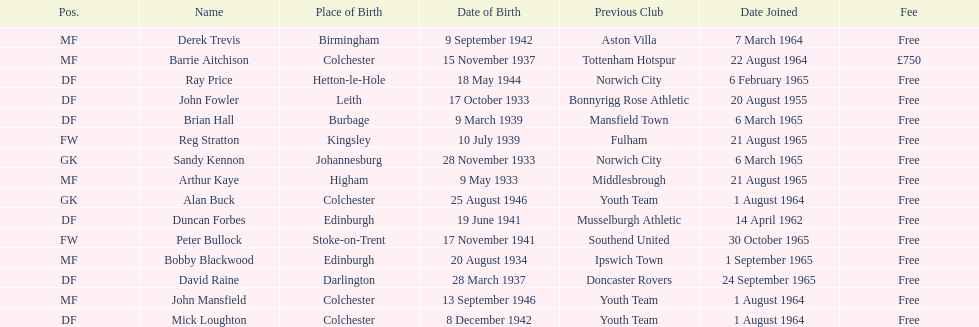Which player is the oldest? Arthur Kaye. 